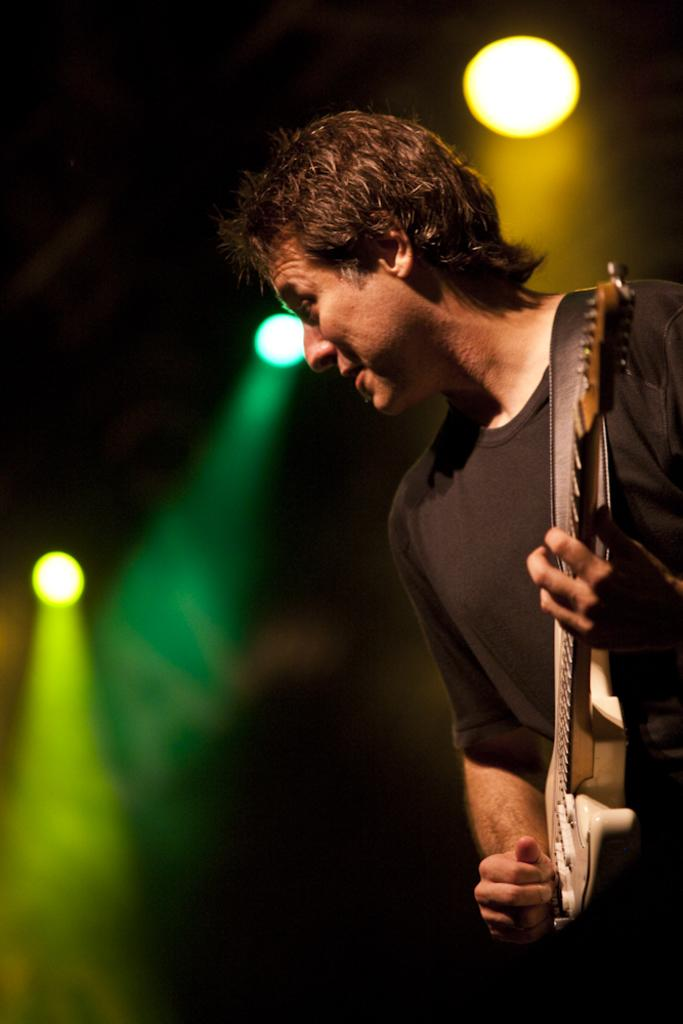What is the man in the image doing? The man is playing a guitar. What is the man wearing in the image? The man is wearing a black T-shirt. What can be seen in the background of the image? There are show lights in the background of the image. What colors are the show lights? The show lights are of yellow, green, and blue colors. What type of government is depicted in the image? There is no depiction of a government in the image; it features a man playing a guitar with show lights in the background. Can you see a toad in the image? There is no toad present in the image. 